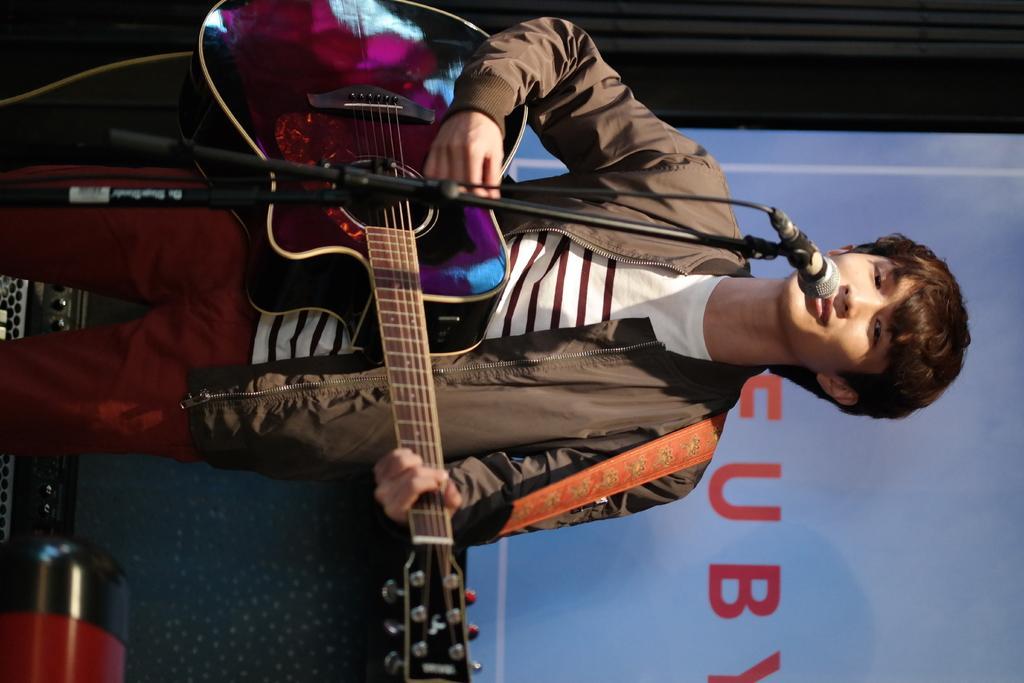Could you give a brief overview of what you see in this image? In this picture we can see a boy holding a guitar with his left hand, and playing the guitar with his right hand. He is wearing a jacket, t-shirt and a pant. Also there is a screen behind him displaying some name. 